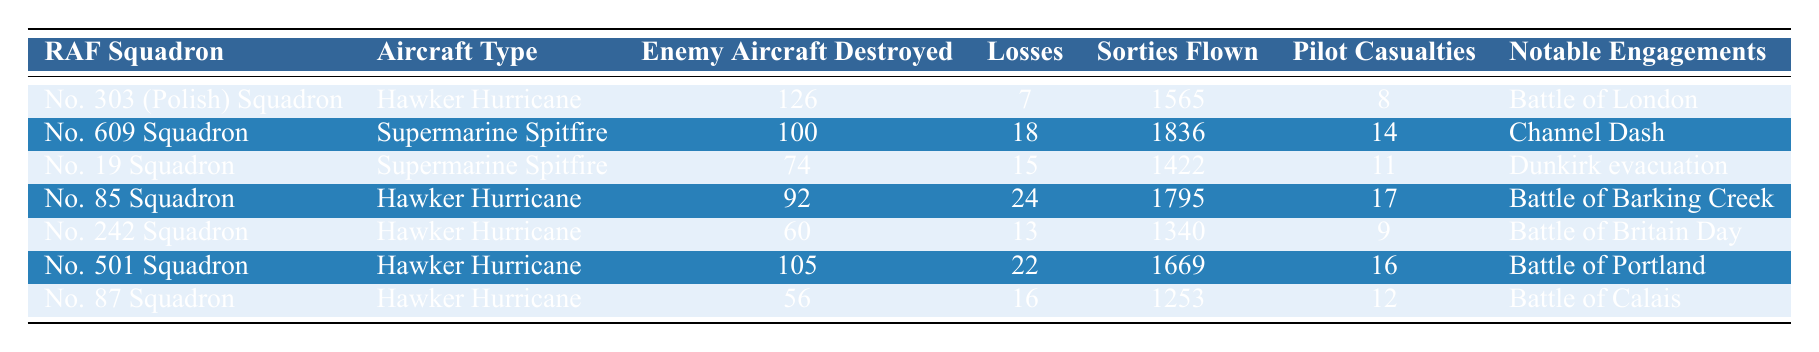What is the aircraft type used by No. 609 Squadron? The table lists the aircraft type alongside each RAF Squadron. For No. 609 Squadron, the corresponding aircraft type is found in the second column, which is Supermarine Spitfire.
Answer: Supermarine Spitfire How many enemy aircraft were destroyed by No. 303 (Polish) Squadron? The number of enemy aircraft destroyed by each squadron is provided in the third column. For No. 303 (Polish) Squadron, this value is 126.
Answer: 126 Which squadron had the highest number of losses? To find the squadron with the highest losses, we look at the fourth column for each squadron. Comparing the values, No. 85 Squadron has the highest losses at 24.
Answer: No. 85 Squadron What is the total number of sorties flown by No. 87 Squadron? The total number of sorties for each squadron is recorded in the fifth column. For No. 87 Squadron, the number of sorties flown is 1253 as per the table.
Answer: 1253 How many pilot casualties were there for the squadron with the lowest enemy aircraft destroyed? First, we identify the squadron with the lowest number of enemy aircraft destroyed, which is No. 87 Squadron with 56. Then, we check the sixth column for pilot casualties related to that squadron, which is 12.
Answer: 12 Which squadron engaged in the Battle of Dunkirk evacuation, and how many enemy aircraft did they destroy? The notable engagements are in the last column. No. 19 Squadron is listed for Dunkirk evacuation. Checking the third column for enemy aircraft destroyed, they achieved 74.
Answer: No. 19 Squadron, 74 If you sum the enemy aircraft destroyed by No. 609 Squadron and No. 501 Squadron, what is the result? The values of enemy aircraft destroyed for No. 609 Squadron is 100, and for No. 501 Squadron it is 105. Summing them gives: 100 + 105 = 205.
Answer: 205 Which squadron lost the most pilots, and how many were lost? To find the squadron with the most pilot casualties, we examine the sixth column. No. 85 Squadron had the highest number of pilot casualties, which is 17.
Answer: No. 85 Squadron, 17 What is the average number of enemy aircraft destroyed across all squadrons? First, we sum the number of enemy aircraft destroyed: 126 + 100 + 74 + 92 + 60 + 105 + 56 = 713. There are 7 squadrons, so the average is 713 / 7 ≈ 101.857, which we can round to 102 for simplicity.
Answer: 102 Did any squadron have a higher number of losses than enemy aircraft destroyed? We compare the values in the fourth column (losses) and the third column (enemy aircraft destroyed) for each squadron. No. 85 Squadron had 24 losses while destroying 92 enemy aircraft, meaning it is a no.
Answer: No 